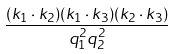Convert formula to latex. <formula><loc_0><loc_0><loc_500><loc_500>\frac { ( k _ { 1 } \cdot k _ { 2 } ) ( k _ { 1 } \cdot k _ { 3 } ) ( k _ { 2 } \cdot k _ { 3 } ) } { q _ { 1 } ^ { 2 } q _ { 2 } ^ { 2 } }</formula> 